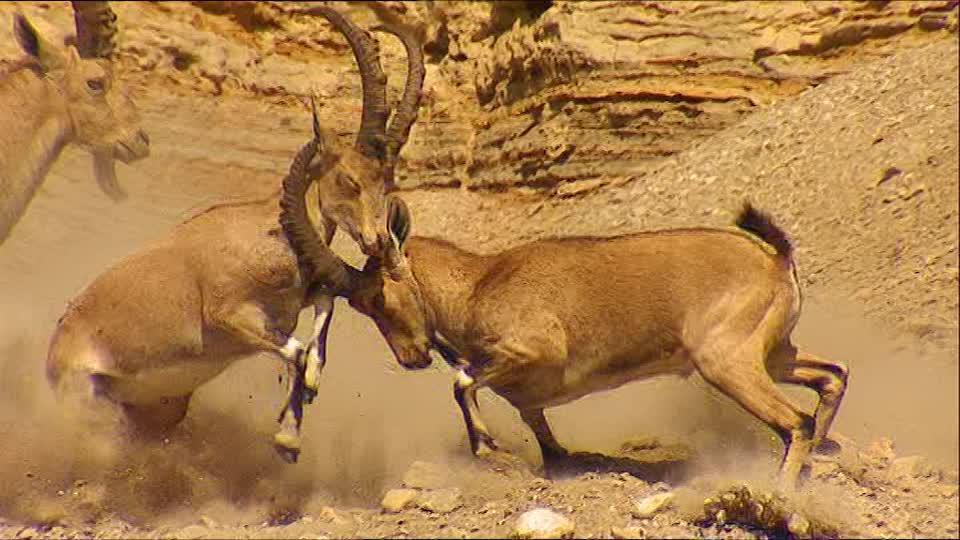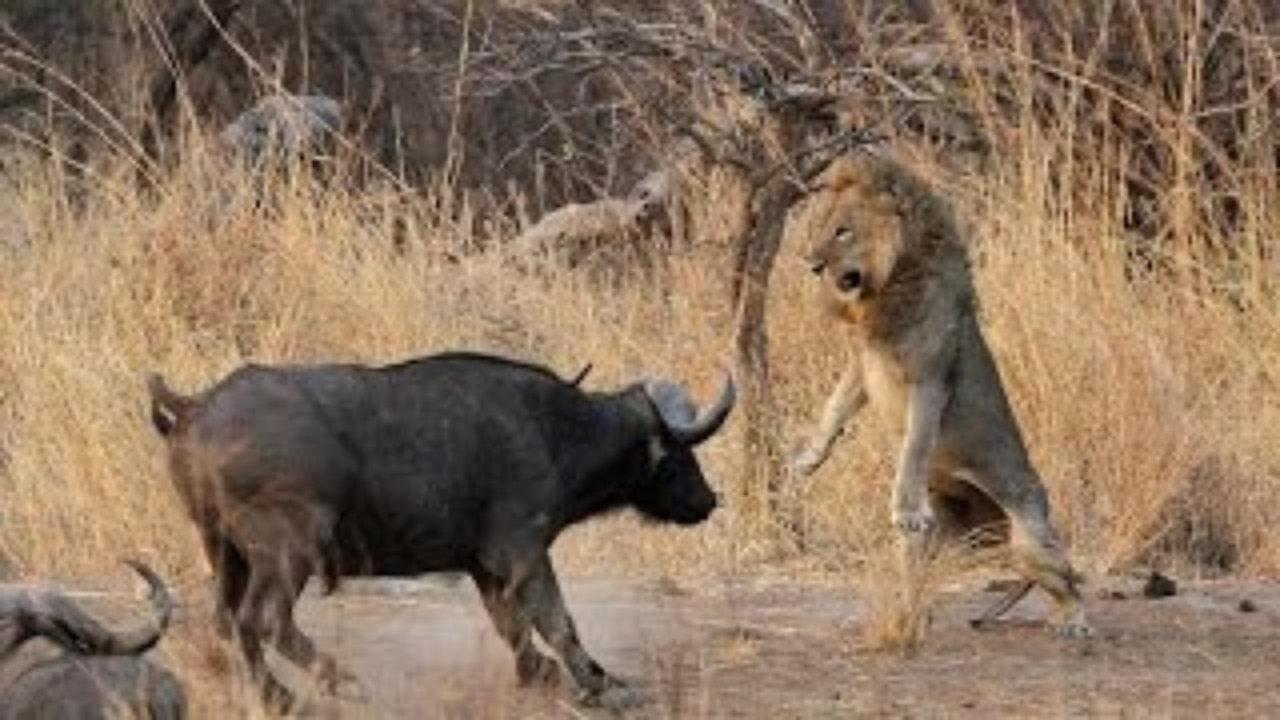The first image is the image on the left, the second image is the image on the right. For the images displayed, is the sentence "The left and right image contains the total  of five rams." factually correct? Answer yes or no. No. The first image is the image on the left, the second image is the image on the right. Evaluate the accuracy of this statement regarding the images: "There is exactly two mountain goats in the right image.". Is it true? Answer yes or no. No. 